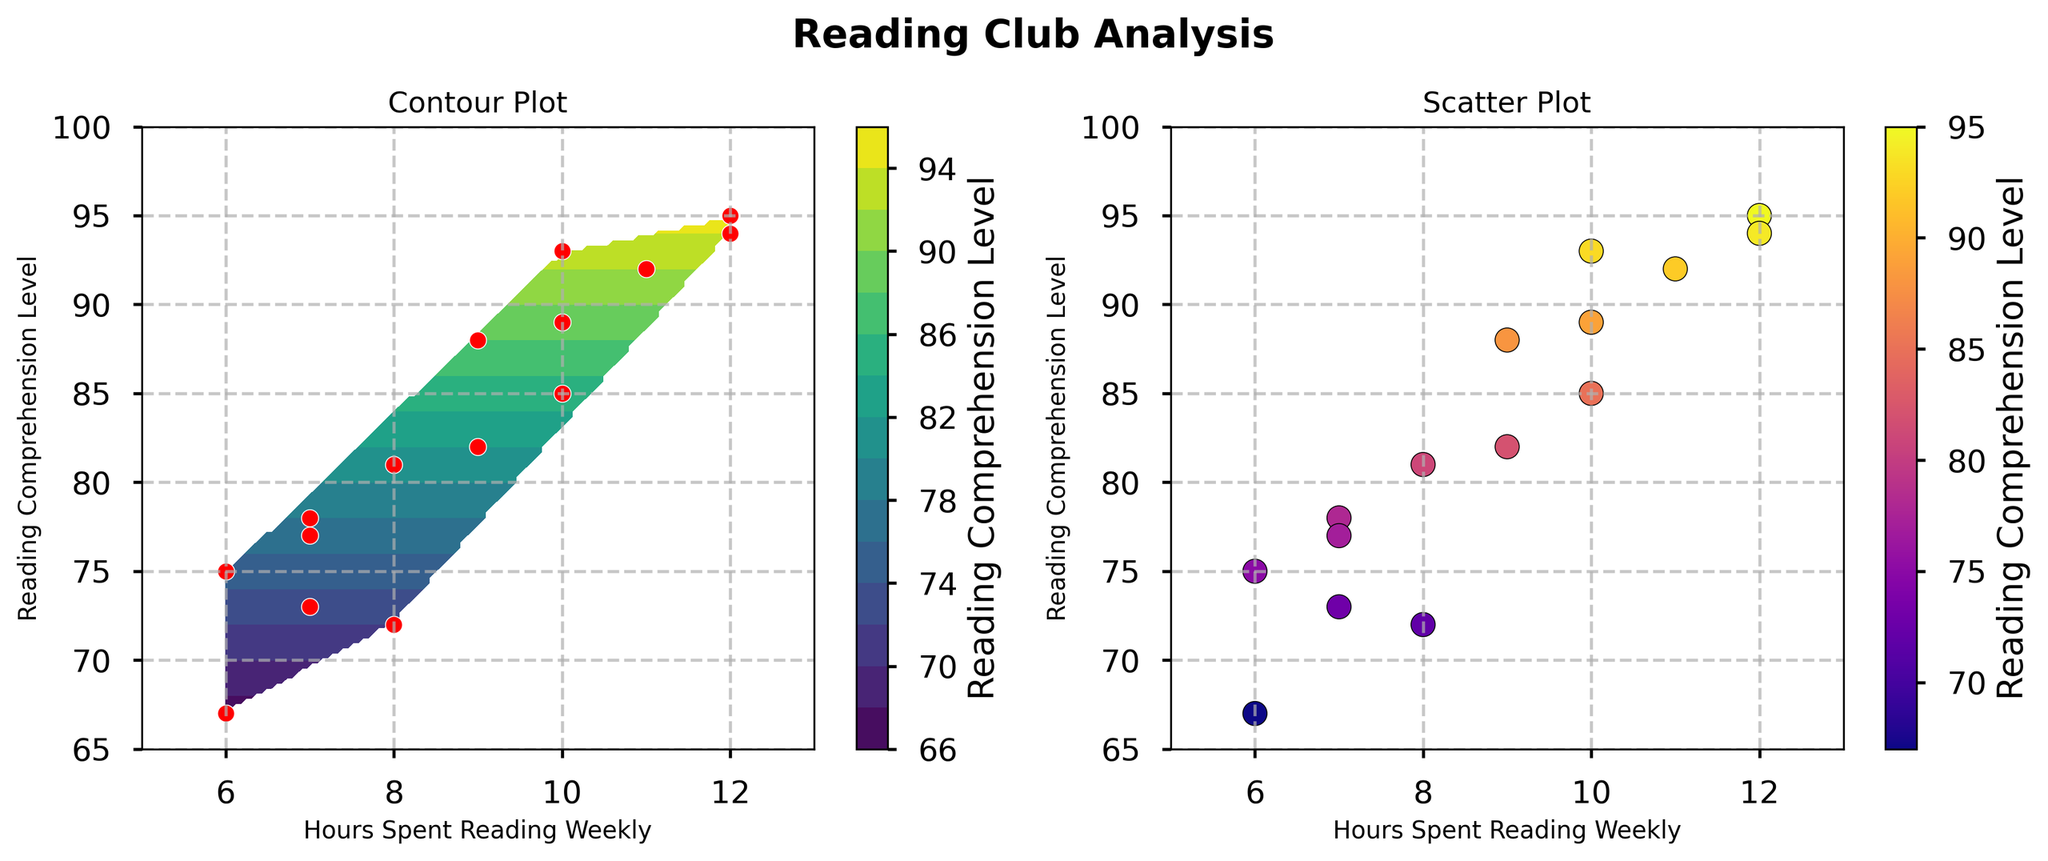What is the title of the contour plot? The title of the contour plot is generally located at the top center of the plot. By looking at the figure, you can see the title labeled above the contour plot.
Answer: Contour Plot How many data points are shown in red on the contour plot? On the contour plot, each red dot represents a data point. We can count the number of red dots visible on the plot.
Answer: 15 What is the range of hours spent reading weekly? The X-axis of the plots represents the hours spent reading weekly. By examining the range of values on this axis, we see it spans from approximately 6 to 12 hours.
Answer: 6 to 12 What is the highest reading comprehension level observed in the scatter plot? To find the highest reading comprehension level, we look at the Y-axis of the scatter plot and identify the highest data point.
Answer: 95 Which plot has a color bar labeled "Reading Comprehension Level"? By observing both subplots, we see which one includes a color bar labeled with the Reading Comprehension Level. The color bar helps indicate the intensity of the reading comprehension levels in the plot.
Answer: Both Is there a positive or negative correlation between hours spent reading weekly and reading comprehension level? To determine the correlation, observe the general trend of the data points in the scatter plot. The data points appear to move upward as we move to the right, indicating that higher hours spent reading weekly tend to correspond with higher reading comprehension levels.
Answer: Positive Do any data points show both high reading comprehension levels and lower hours spent reading weekly? We need to look for data points that combine a high reading comprehension level (near the top of the Y-axis) with lower hours spent reading weekly (towards the left of the X-axis).
Answer: No What color scheme is used for the contour plot? The color scheme can be identified by observing the gradient and colors filled in the contour lines. The plot specifies which colormap is used.
Answer: Viridis Are there more data points with reading comprehension levels above 80 or below 80? By counting the number of data points above and below the reading comprehension level of 80 in either of the plots, we can determine which group is larger.
Answer: Above 80 What is the overall trend shown in the scatter plot? By examining how the data points are distributed in the scatter plot, we can summarize the overall trend.
Answer: As hours spent reading increase, reading comprehension levels tend to increase 